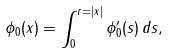<formula> <loc_0><loc_0><loc_500><loc_500>\phi _ { 0 } ( x ) = \int _ { 0 } ^ { r = | x | } \phi _ { 0 } ^ { \prime } ( s ) \, d s ,</formula> 